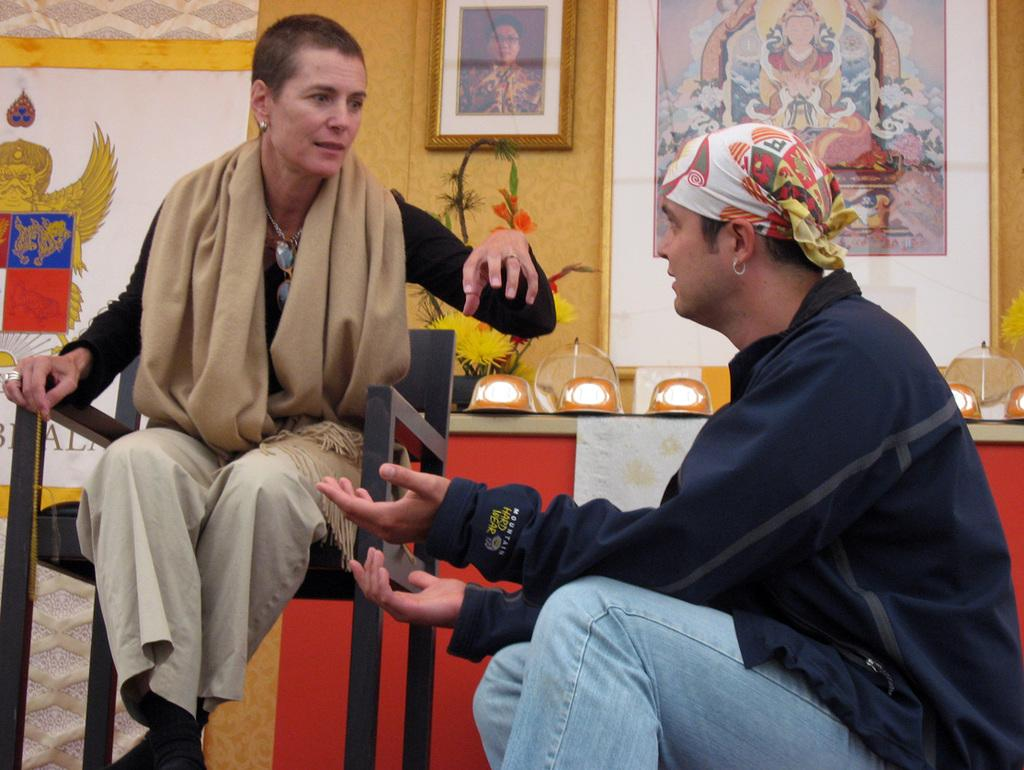Who is present in the image? There is a man and a woman in the image. What are the man and woman doing in the image? The man and woman are sitting and talking in the image. What can be seen on the wall in the background of the image? There are frames attached to the wall in the background of the image. What object can be seen on a surface in the image? There is a flower vase in the image. Who is the owner of the chalk in the image? There is no chalk present in the image. What type of house is depicted in the image? The image does not show a house; it features a man and a woman sitting and talking, with frames on the wall and a flower vase. 